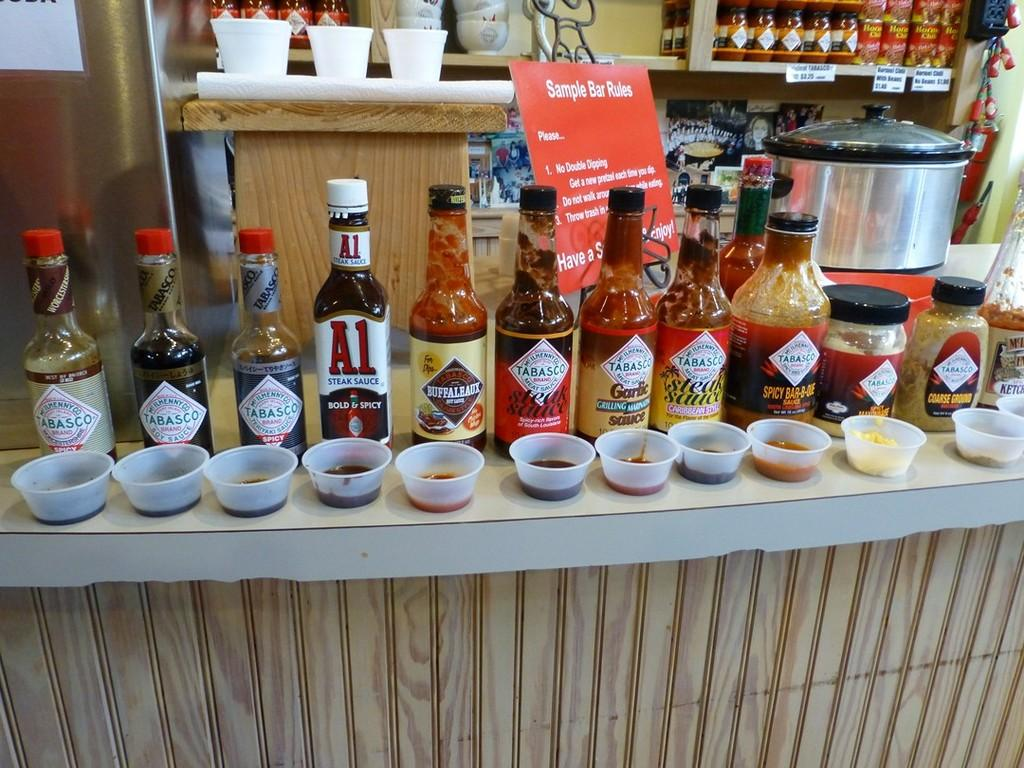<image>
Give a short and clear explanation of the subsequent image. A sample bar with many jars of Tabasco and A1 Steak Sauce with a sign that says Sample Bar Rules 